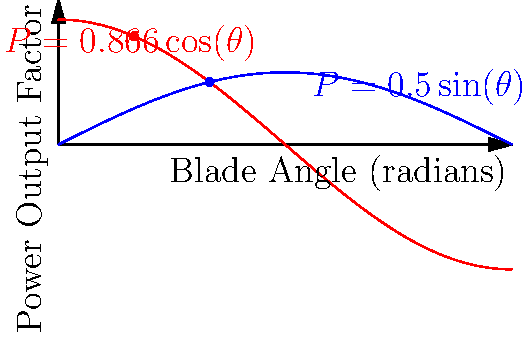A wind turbine's power output is affected by the angle of its blades relative to the wind direction. Two different blade designs are being considered:

Design A: $P = 0.5\sin(\theta)$
Design B: $P = 0.866\cos(\theta)$

Where $P$ is the power output factor and $\theta$ is the blade angle in radians.

Which design produces the maximum power output, and at what angle does this occur? To find the maximum power output for each design, we need to determine the angle that maximizes each function:

1. For Design A: $P = 0.5\sin(\theta)$
   The maximum of sine occurs at $\theta = \frac{\pi}{2}$ radians (90°).
   Maximum power: $P_A = 0.5\sin(\frac{\pi}{2}) = 0.5$

2. For Design B: $P = 0.866\cos(\theta)$
   The maximum of cosine occurs at $\theta = 0$ radians (0°).
   Maximum power: $P_B = 0.866\cos(0) = 0.866$

Comparing the two maximum values:
$P_B = 0.866 > P_A = 0.5$

Therefore, Design B produces the maximum power output of 0.866 at an angle of 0 radians (0°).
Answer: Design B, 0 radians (0°) 